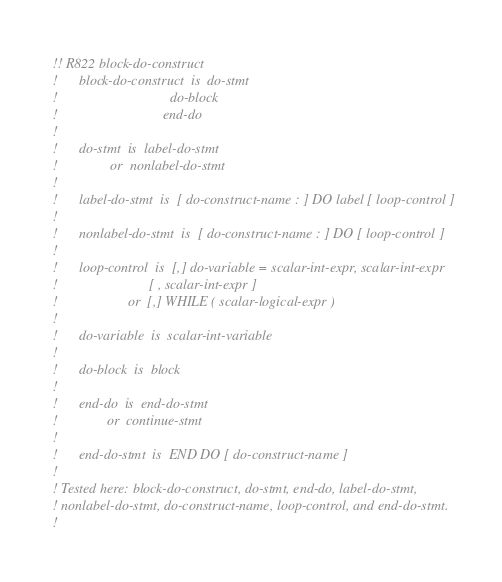<code> <loc_0><loc_0><loc_500><loc_500><_FORTRAN_>!! R822 block-do-construct
!      block-do-construct  is  do-stmt
!                                do-block
!                              end-do
!
!      do-stmt  is  label-do-stmt
!               or  nonlabel-do-stmt
!
!      label-do-stmt  is  [ do-construct-name : ] DO label [ loop-control ]
!
!      nonlabel-do-stmt  is  [ do-construct-name : ] DO [ loop-control ]
!
!      loop-control  is  [,] do-variable = scalar-int-expr, scalar-int-expr
!                          [ , scalar-int-expr ]
!                    or  [,] WHILE ( scalar-logical-expr )
!
!      do-variable  is  scalar-int-variable
!
!      do-block  is  block
!
!      end-do  is  end-do-stmt
!              or  continue-stmt
!
!      end-do-stmt  is  END DO [ do-construct-name ]
!
! Tested here: block-do-construct, do-stmt, end-do, label-do-stmt, 
! nonlabel-do-stmt, do-construct-name, loop-control, and end-do-stmt.
! </code> 